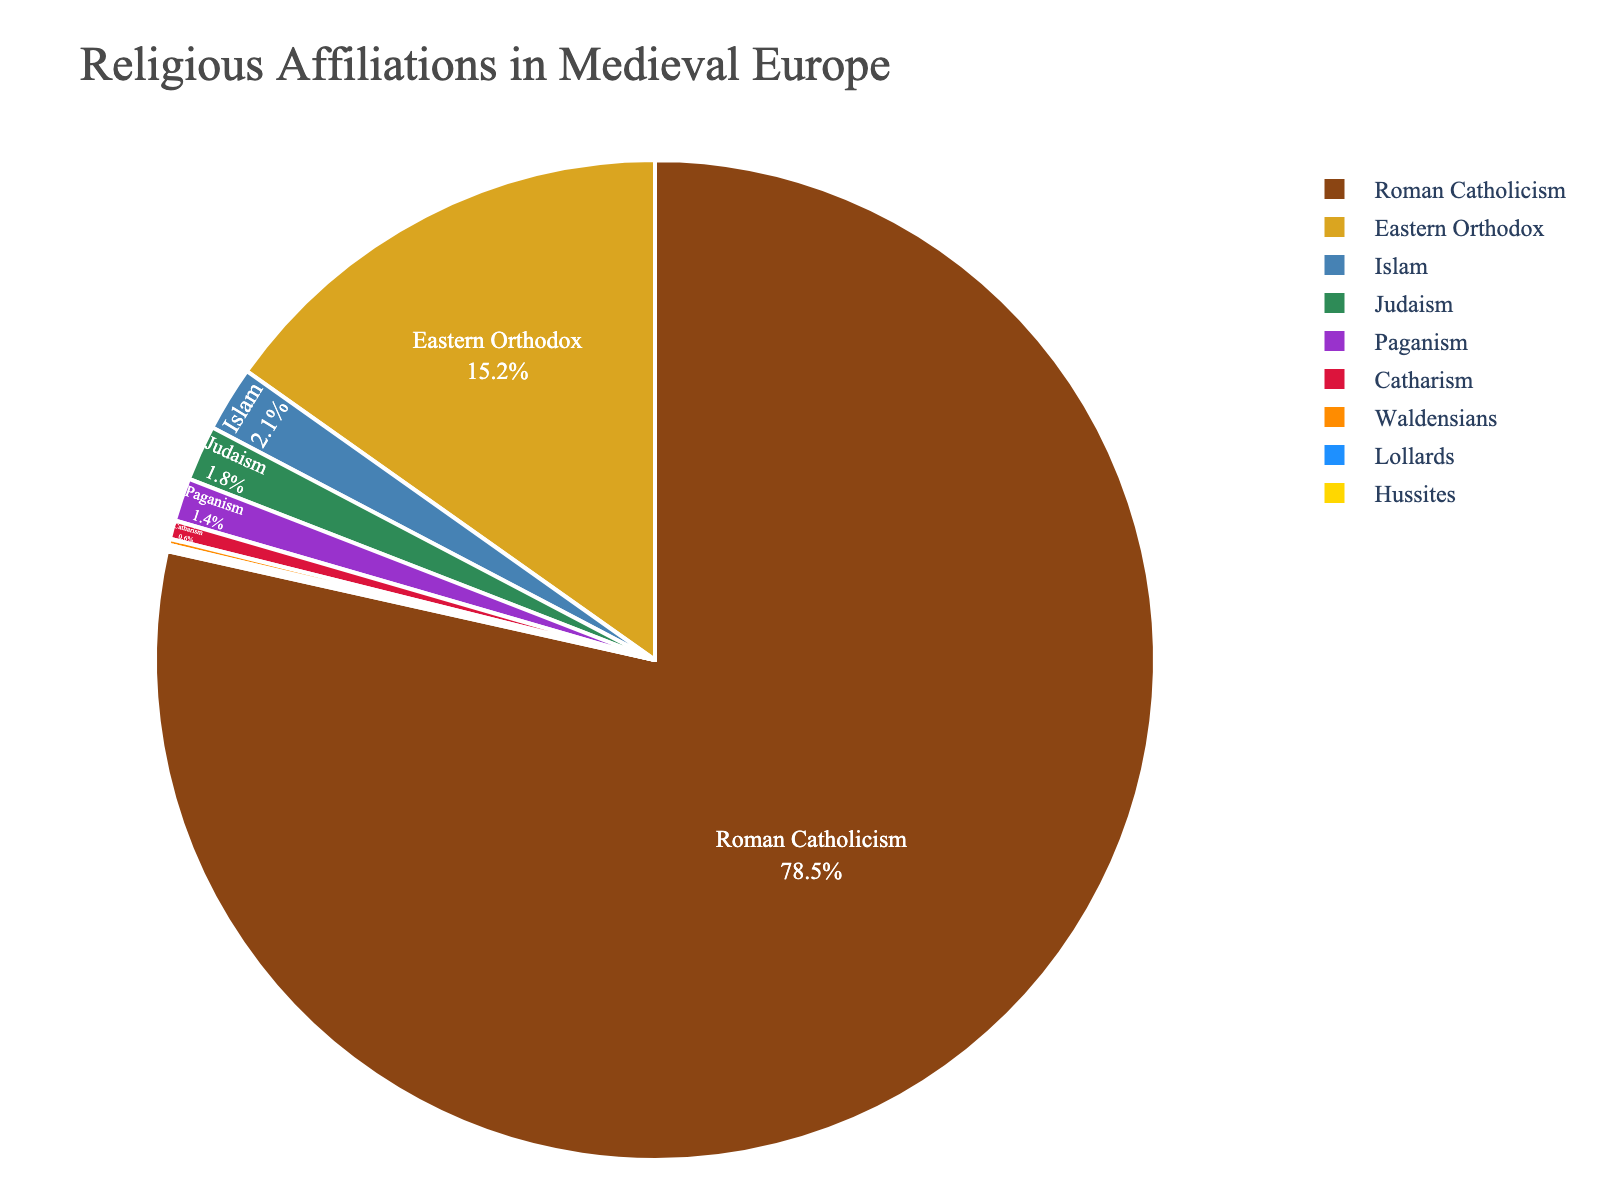what is the most common religious affiliation in medieval Europe based on the figure? The figure shows various religious affiliations, each represented by different colors and percentages. The largest portion of the pie chart, identified by the highest percentage, represents the most common religious affiliation. Roman Catholicism has the largest slice at 78.5%.
Answer: Roman Catholicism which religious affiliation has the smallest percentage? By looking at the slices of the pie chart, the smallest slice corresponds to the smallest percentage, which belongs to Lollards at 0.1%.
Answer: Lollards what is the combined percentage of Eastern Orthodox and Islam? To find the combined percentage, add the percentage values of Eastern Orthodox and Islam. Eastern Orthodox is 15.2% and Islam is 2.1%. So, 15.2 + 2.1 = 17.3%.
Answer: 17.3% how does the percentage of Judaism compare to that of Paganism? By comparing the slices representing Judaism and Paganism, we can see that Judaism has a percentage of 1.8% and Paganism has 1.4%. Therefore, Judaism has a slightly higher percentage than Paganism.
Answer: Judaism has a higher percentage what percentage of the total religious affiliations are represented by minority religions (less than 2%)? Minority religions have the following percentages: Judaism (1.8%), Islam (2.1%), Paganism (1.4%), Catharism (0.6%), Waldensians (0.2%), Lollards (0.1%), and Hussites (0.1%). Sum these up, but only include those below 2%: 1.8 + 1.4 + 0.6 + 0.2 + 0.1 + 0.1 = 4.2%.
Answer: 4.2% how much larger is the percentage of Roman Catholicism than Eastern Orthodox? Subtract the smaller percentage (Eastern Orthodox) from the larger percentage (Roman Catholicism). Roman Catholicism is 78.5% and Eastern Orthodox is 15.2%. So, 78.5 - 15.2 = 63.3%.
Answer: 63.3% which religions hold more than 10% of the total? By identifying the slices that have percentages greater than 10%, we see that only Roman Catholicism (78.5%) and Eastern Orthodox (15.2%) meet this criterion.
Answer: Roman Catholicism and Eastern Orthodox what is the average percentage of all religions listed in the figure? First, sum all the given percentage values: 78.5 + 15.2 + 1.8 + 2.1 + 1.4 + 0.6 + 0.2 + 0.1 + 0.1 = 100. Then, divide by the number of religions listed, which is 9. So, 100 / 9 ≈ 11.1%.
Answer: 11.1% if you combine the percentages of Catharism, Waldensians, Lollards, and Hussites, what would be their total percentage? Sum the given percentages for these four religions: 0.6% (Catharism) + 0.2% (Waldensians) + 0.1% (Lollards) + 0.1% (Hussites) = 1.0%.
Answer: 1.0% 